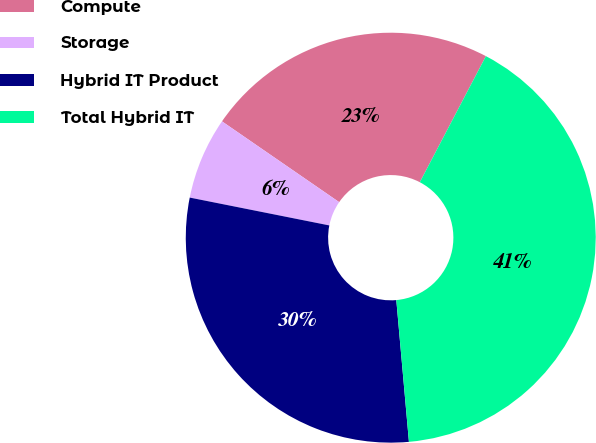Convert chart to OTSL. <chart><loc_0><loc_0><loc_500><loc_500><pie_chart><fcel>Compute<fcel>Storage<fcel>Hybrid IT Product<fcel>Total Hybrid IT<nl><fcel>23.08%<fcel>6.47%<fcel>29.55%<fcel>40.9%<nl></chart> 